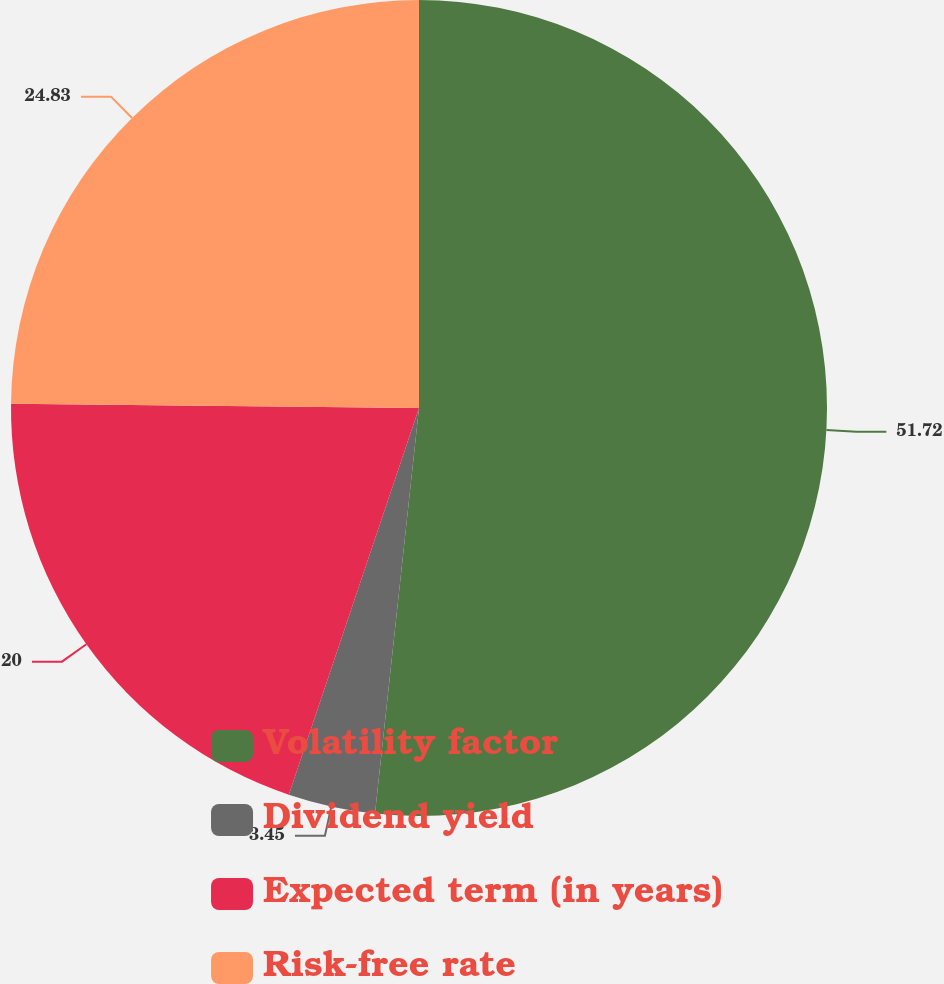Convert chart to OTSL. <chart><loc_0><loc_0><loc_500><loc_500><pie_chart><fcel>Volatility factor<fcel>Dividend yield<fcel>Expected term (in years)<fcel>Risk-free rate<nl><fcel>51.72%<fcel>3.45%<fcel>20.0%<fcel>24.83%<nl></chart> 